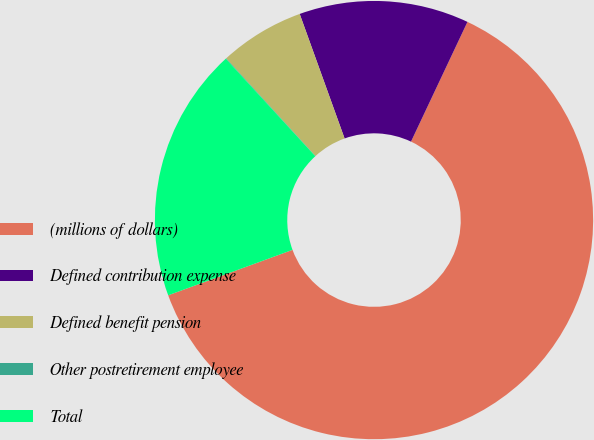Convert chart to OTSL. <chart><loc_0><loc_0><loc_500><loc_500><pie_chart><fcel>(millions of dollars)<fcel>Defined contribution expense<fcel>Defined benefit pension<fcel>Other postretirement employee<fcel>Total<nl><fcel>62.41%<fcel>12.52%<fcel>6.28%<fcel>0.04%<fcel>18.75%<nl></chart> 